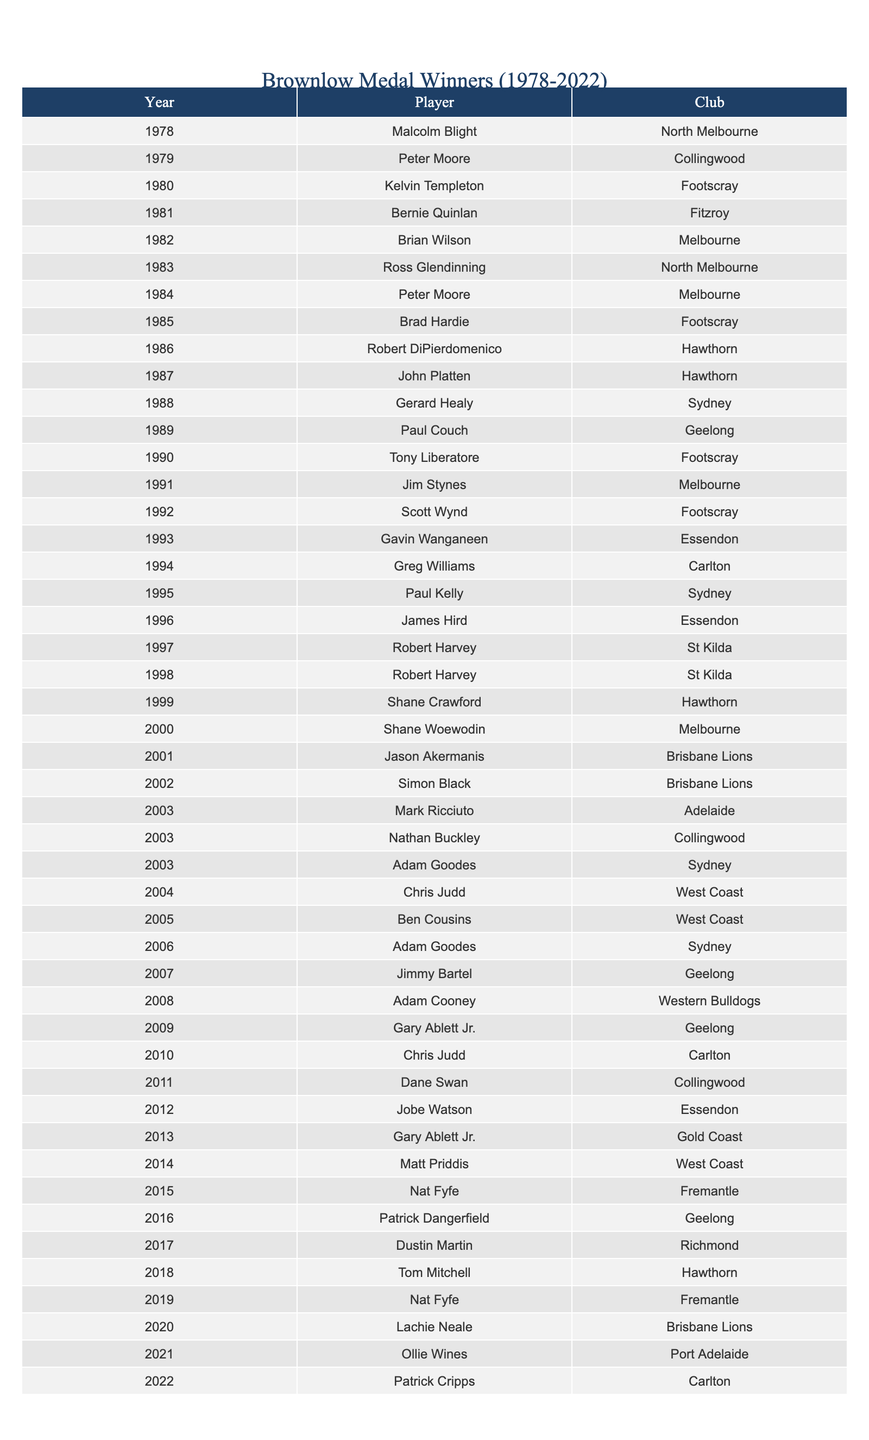What year did the first Brownlow Medal winner, Malcolm Blight, come from North Melbourne? According to the table, Malcolm Blight won the Brownlow Medal in 1978 while playing for North Melbourne.
Answer: 1978 Who won the Brownlow Medal in 1995 and which club did he represent? The table shows that Paul Kelly won the Brownlow Medal in 1995, representing Sydney.
Answer: Paul Kelly, Sydney How many players have won the Brownlow Medal from the club Geelong? By counting the entries in the table, Geelong players have won the Brownlow Medal three times: Paul Couch in 1989, Gary Ablett Jr. in 2009, and Patrick Dangerfield in 2016.
Answer: Three Which player has won the Brownlow Medal the most times? The table contains Robert Harvey who won the Brownlow Medal in 1997 and again in 1998, making him the only player with two wins listed here.
Answer: Robert Harvey Is there a player who won the Brownlow Medal in consecutive years? Looking through the data, there is no player listed who won in consecutive years within the provided data.
Answer: No What is the earliest year in the table that a player from West Coast won the Brownlow Medal? According to the table, Chris Judd won the Brownlow Medal in 2004, which is the earliest entry for a West Coast player.
Answer: 2004 How many players shared the Brownlow Medal in 2003? The table shows that three players shared the Brownlow Medal in 2003: Mark Ricciuto from Adelaide, Nathan Buckley from Collingwood, and Adam Goodes from Sydney.
Answer: Three What is the total number of different clubs represented in the list of Brownlow Medal winners from 1978 to 2022? By reviewing the table, there are 13 different clubs represented in the winners.
Answer: Thirteen Which player scored a win for Port Adelaide and in what year? The table indicates that Ollie Wines won the Brownlow Medal in 2021 while representing Port Adelaide.
Answer: Ollie Wines, 2021 Looking at the years from 2000 to 2022, how many times did players from Sydney win the Brownlow Medal? There were three players from Sydney who won the Brownlow Medal between 2000 and 2022: Paul Kelly in 1995, Adam Goodes in 2006, and again in 2014.
Answer: Three 